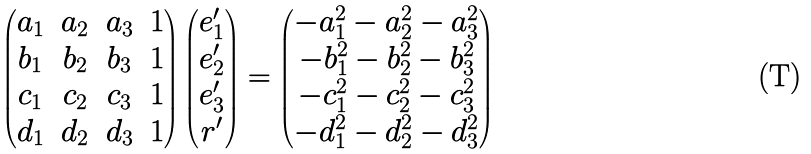<formula> <loc_0><loc_0><loc_500><loc_500>\begin{pmatrix} a _ { 1 } & a _ { 2 } & a _ { 3 } & 1 \\ b _ { 1 } & b _ { 2 } & b _ { 3 } & 1 \\ c _ { 1 } & c _ { 2 } & c _ { 3 } & 1 \\ d _ { 1 } & d _ { 2 } & d _ { 3 } & 1 \end{pmatrix} \begin{pmatrix} e _ { 1 } ^ { \prime } \\ e _ { 2 } ^ { \prime } \\ e _ { 3 } ^ { \prime } \\ r ^ { \prime } \end{pmatrix} = \begin{pmatrix} - a _ { 1 } ^ { 2 } - a _ { 2 } ^ { 2 } - a _ { 3 } ^ { 2 } \\ - b _ { 1 } ^ { 2 } - b _ { 2 } ^ { 2 } - b _ { 3 } ^ { 2 } \\ - c _ { 1 } ^ { 2 } - c _ { 2 } ^ { 2 } - c _ { 3 } ^ { 2 } \\ - d _ { 1 } ^ { 2 } - d _ { 2 } ^ { 2 } - d _ { 3 } ^ { 2 } \end{pmatrix}</formula> 